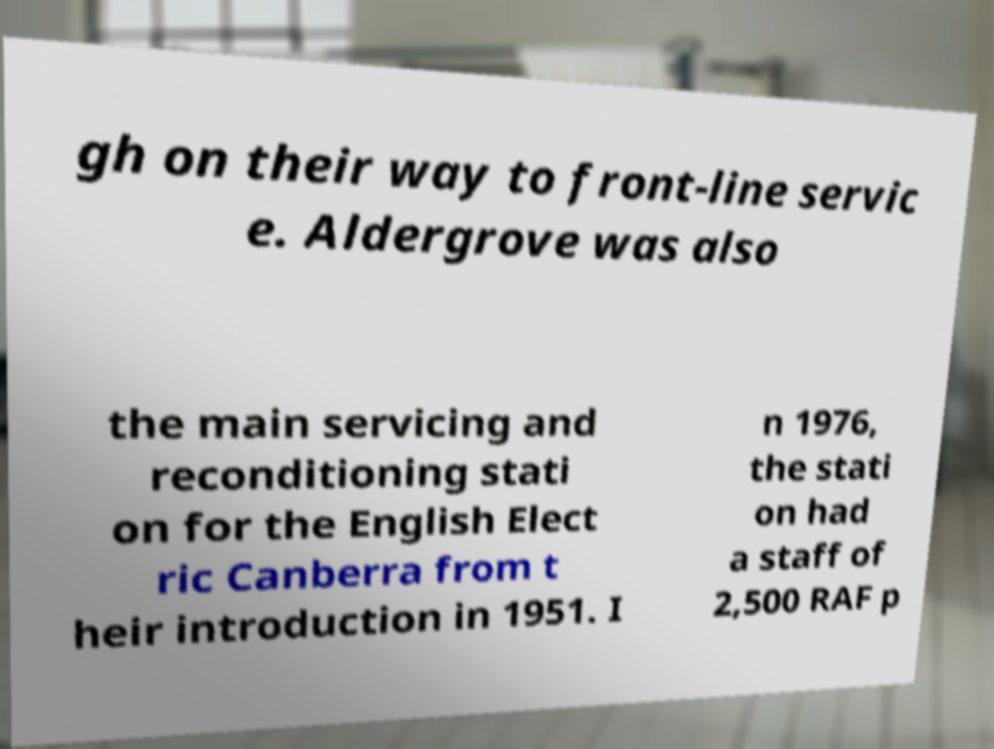Can you accurately transcribe the text from the provided image for me? gh on their way to front-line servic e. Aldergrove was also the main servicing and reconditioning stati on for the English Elect ric Canberra from t heir introduction in 1951. I n 1976, the stati on had a staff of 2,500 RAF p 